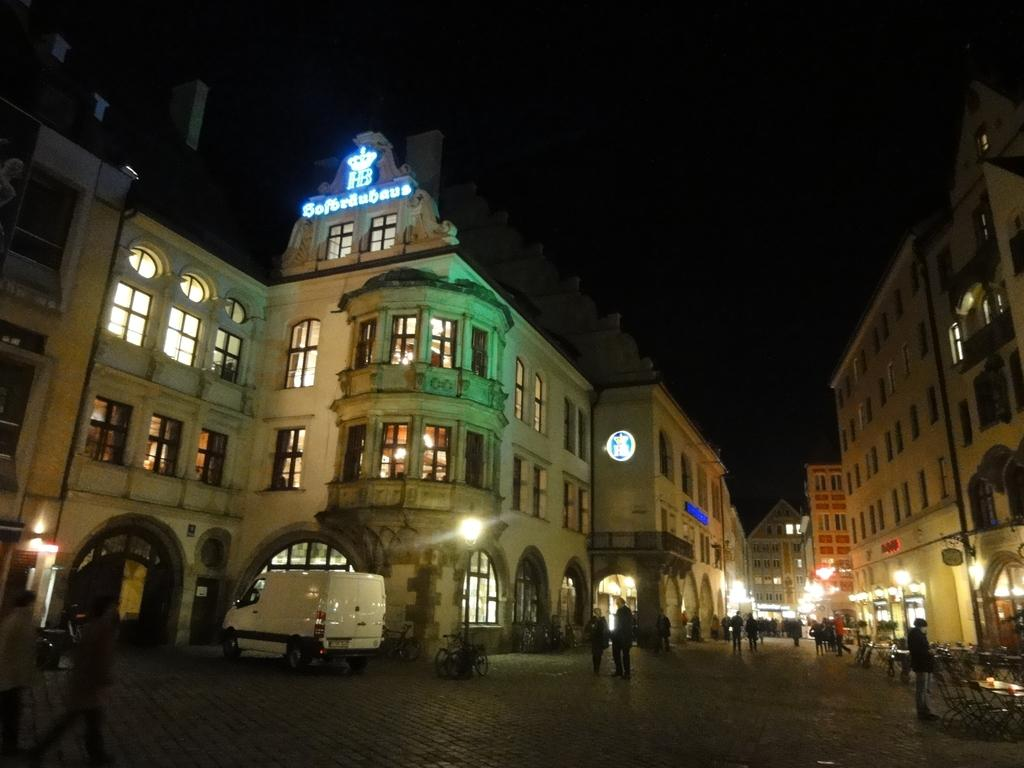What types of objects are present in the image? There are vehicles, a group of people, poles, lights, buildings, chairs, and tables in the image. Can you describe the group of people in the image? The image shows a group of people standing. What are the poles used for in the image? The purpose of the poles is not clear from the image, but they could be used for various purposes such as supporting structures or holding signs. What type of lighting is present in the image? There are lights in the image, but their specific type is not mentioned. What structures are visible in the image? Buildings are visible in the image. Where is the bat hiding in the image? There is no bat present in the image. What type of kettle is being used to make tea in the image? There is no kettle or tea-making activity in the image. 